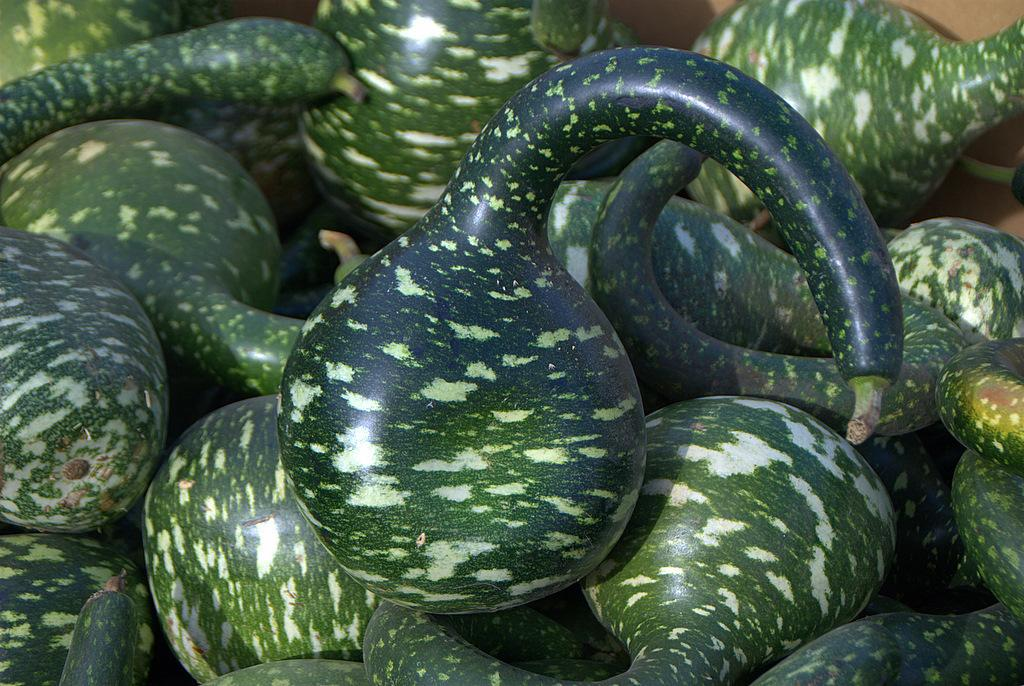What is the focus of the image? The image is zoomed in, so the focus is on a specific area. What can be seen in the center of the image? There are green color objects in the center of the image. What are the green color objects identified as? The green color objects are identified as gourds. How many sisters are present in the image? There are no people, including sisters, present in the image; it only features gourds. What type of bread can be seen in the image? There is no bread present in the image; it only features gourds. 